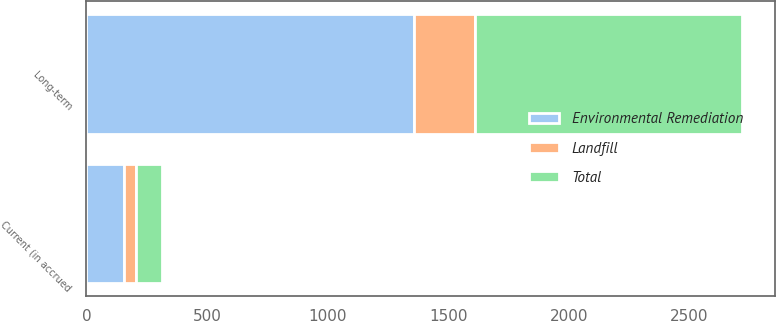Convert chart to OTSL. <chart><loc_0><loc_0><loc_500><loc_500><stacked_bar_chart><ecel><fcel>Current (in accrued<fcel>Long-term<nl><fcel>Total<fcel>108<fcel>1110<nl><fcel>Landfill<fcel>49<fcel>250<nl><fcel>Environmental Remediation<fcel>157<fcel>1360<nl></chart> 